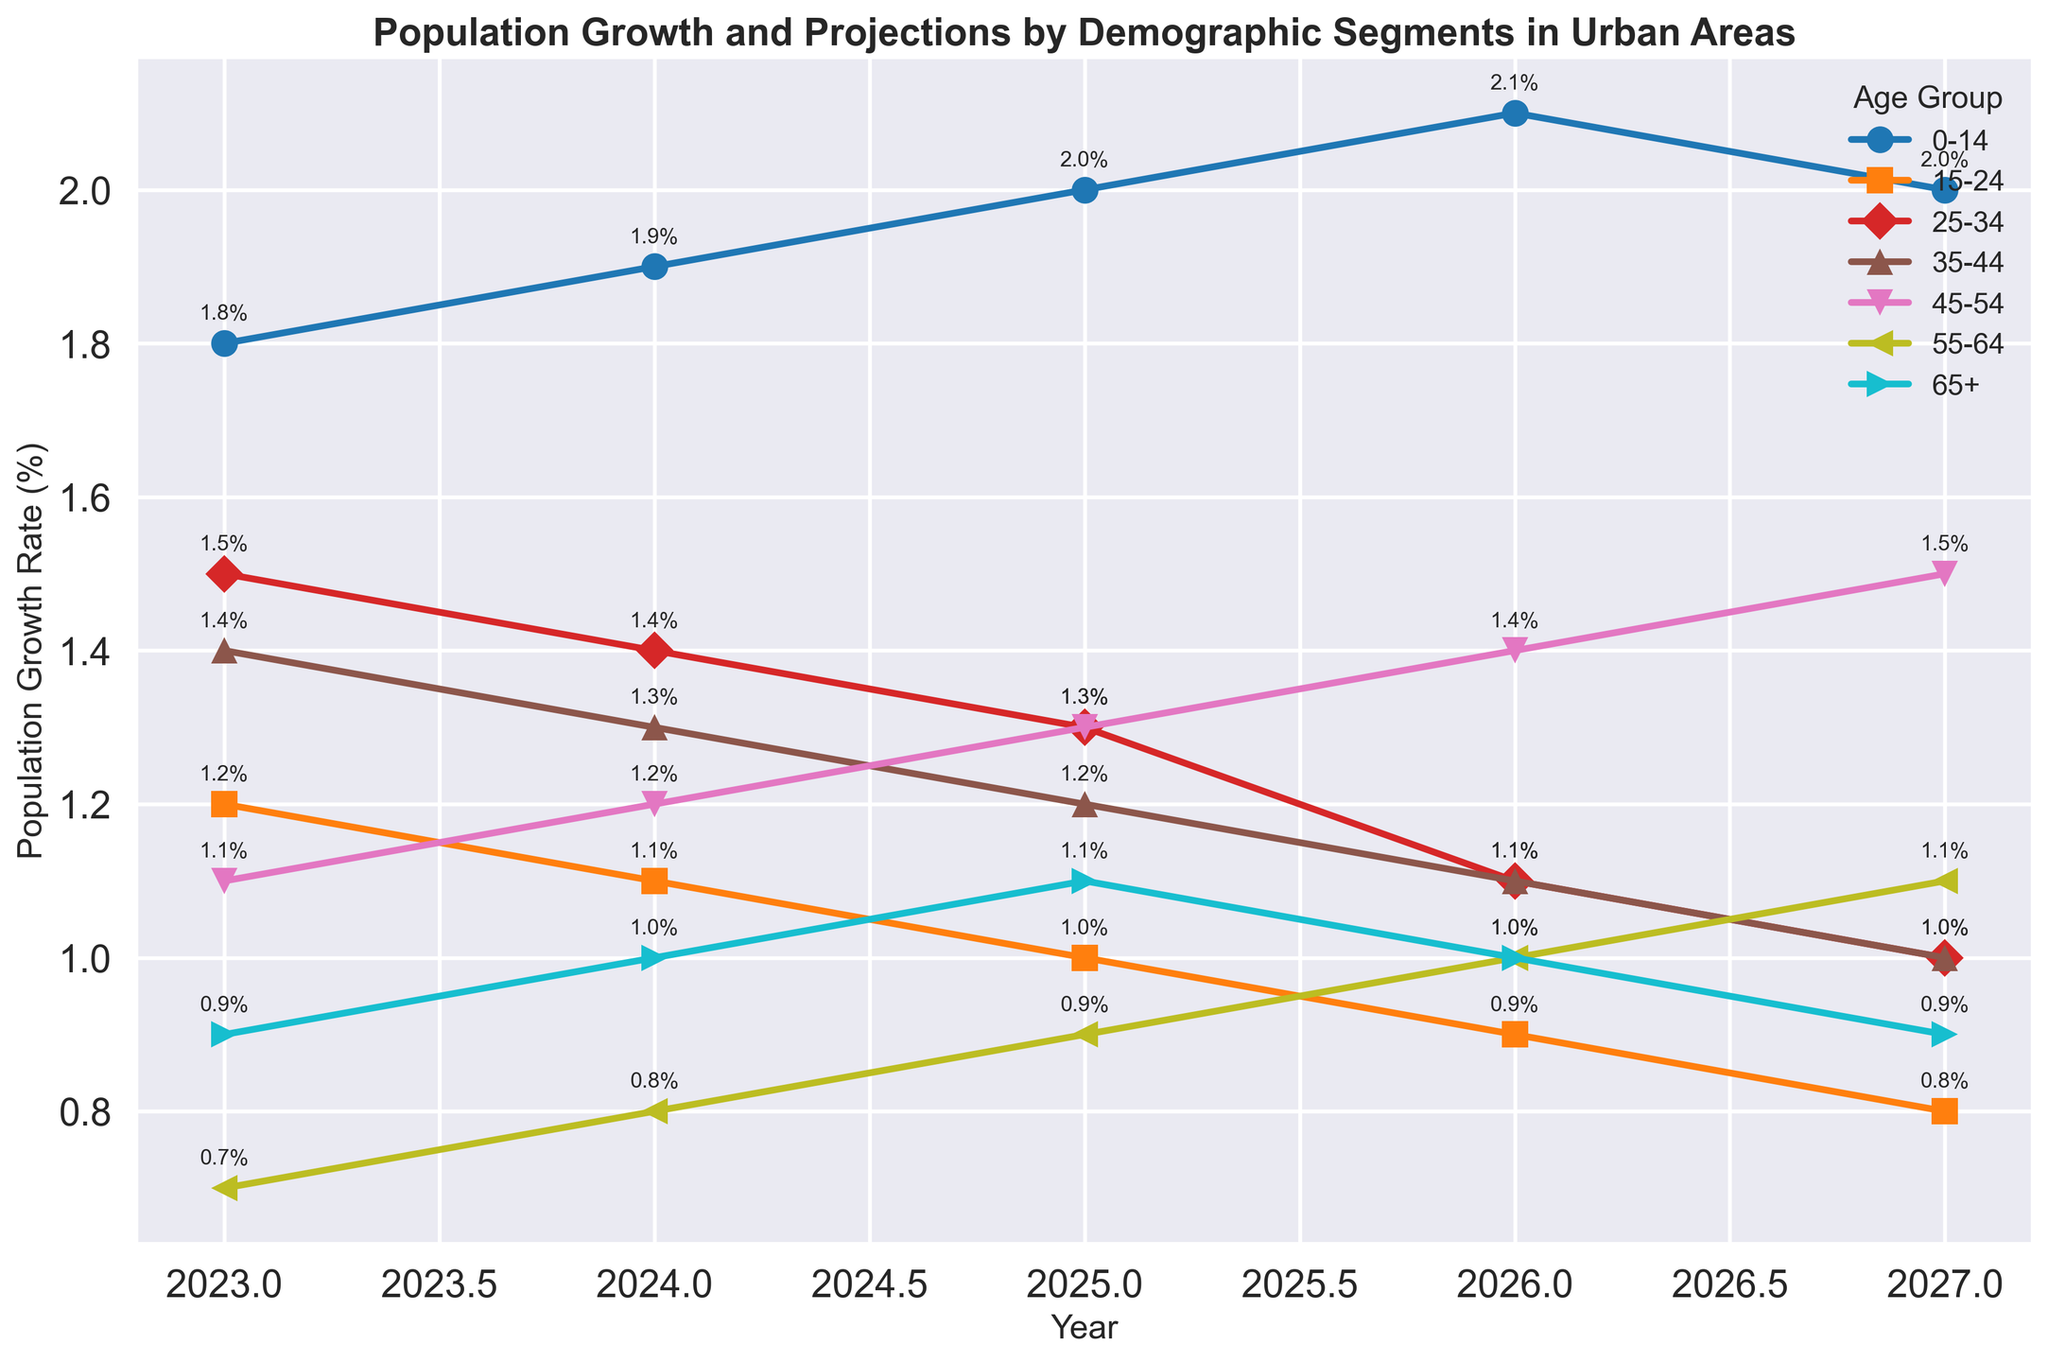What is the population growth rate for the 0-14 age group in 2024? To find the population growth rate for a specific age group in a particular year, locate the relevant data point on the chart. For the 0-14 age group in 2024, the chart shows a growth rate of 1.9%.
Answer: 1.9% Which age group has the highest population growth rate in 2026? To determine which age group has the highest growth rate in 2026, look for the highest point on the graph corresponding to the year 2026. The 0-14 age group has the highest growth rate of 2.1%.
Answer: 0-14 How does the population growth rate for the 25-34 age group change from 2023 to 2027? Examine the points on the graph for the 25-34 age group from 2023 to 2027. In 2023, the rate is 1.5%; it decreases to 1.4% in 2024, 1.3% in 2025, 1.1% in 2026, and finally, 1.0% in 2027.
Answer: It decreases from 1.5% to 1.0% What is the average population growth rate for the 45-54 age group over the years 2023-2027? To calculate the average, sum up the growth rates for the 45-54 age group from 2023 to 2027: (1.1 + 1.2 + 1.3 + 1.4 + 1.5), then divide by the number of years (5). The average is (1.1 + 1.2 + 1.3 + 1.4 + 1.5) / 5 = 6.5 / 5 = 1.3%.
Answer: 1.3% Between which two years does the 15-24 age group experience the most significant decline in growth rate? Observe the points for the 15-24 age group and note any significant changes. The most significant decline occurs between 2026 (0.9%) and 2027 (0.8%).
Answer: 2026 to 2027 What is the trend in population growth for the 65+ age group from 2023 to 2027? Track the growth rates for the 65+ age group across the years. It starts at 0.9% in 2023, then increases to 1.0% in 2024, 1.1% in 2025, returns to 1.0% in 2026, and finally decreases to 0.9% in 2027.
Answer: Fluctuates with a small increase and return to the initial rate Which year shows the highest overall population growth rate for any age group? Check the highest points on the chart across all age groups and years. The highest rate is 2.1% for the 0-14 age group in 2026.
Answer: 2026 Compare the growth rates of the 35-44 age group and the 55-64 age group in 2025. Which is higher? Identify the rates for the two age groups in 2025. The 35-44 age group has a growth rate of 1.2% and the 55-64 age group is at 0.9%. The 35-44 age group is higher.
Answer: 35-44 What is the difference in growth rate between the 15-24 and 25-34 age groups in 2027? Find the growth rates for both age groups in 2027: 15-24 at 0.8% and 25-34 at 1.0%. Subtract the lower rate from the higher rate: 1.0% - 0.8% = 0.2%.
Answer: 0.2% What is the population growth rate trend for the 0-14 age group over the years? The growth rate starts at 1.8% in 2023 and increases each year, reaching 2.1% by 2026, before slightly decreasing to 2.0% in 2027.
Answer: Increasing then slightly decreasing 